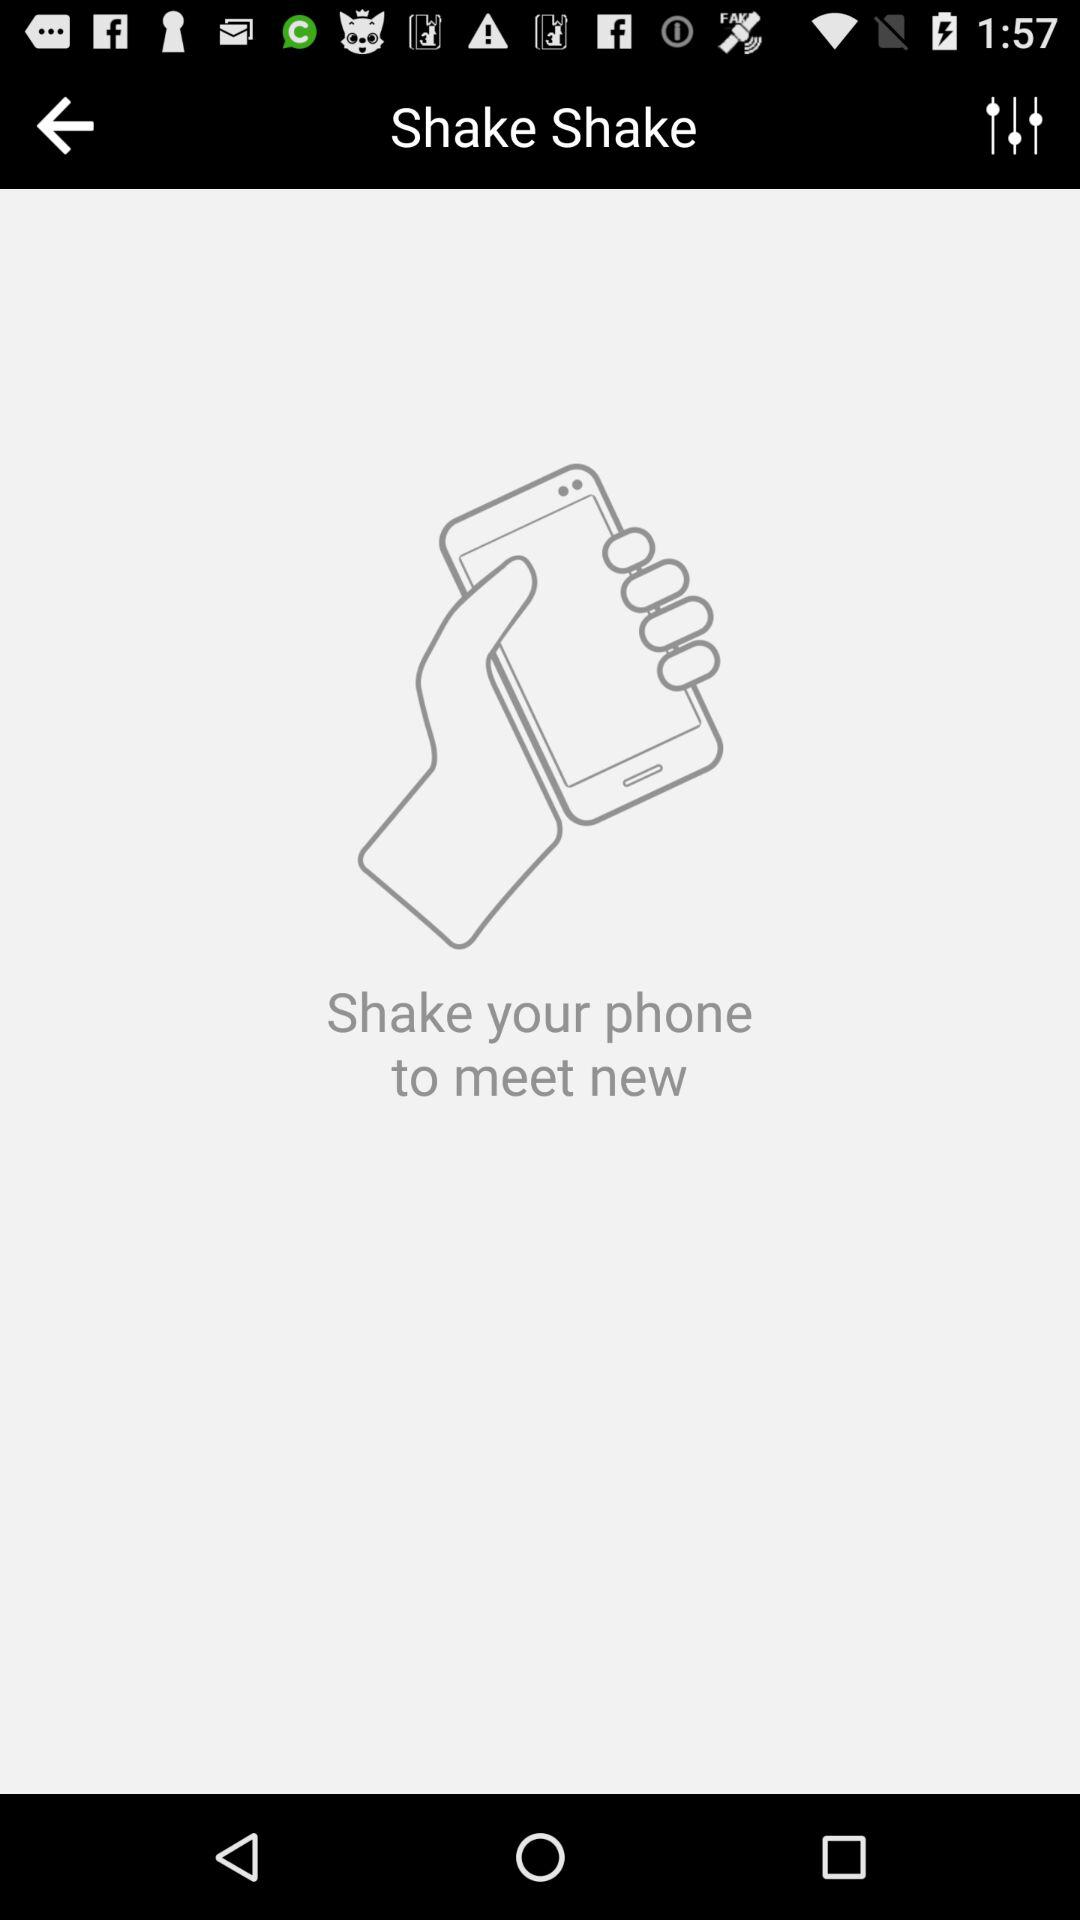What is the application name?
When the provided information is insufficient, respond with <no answer>. <no answer> 